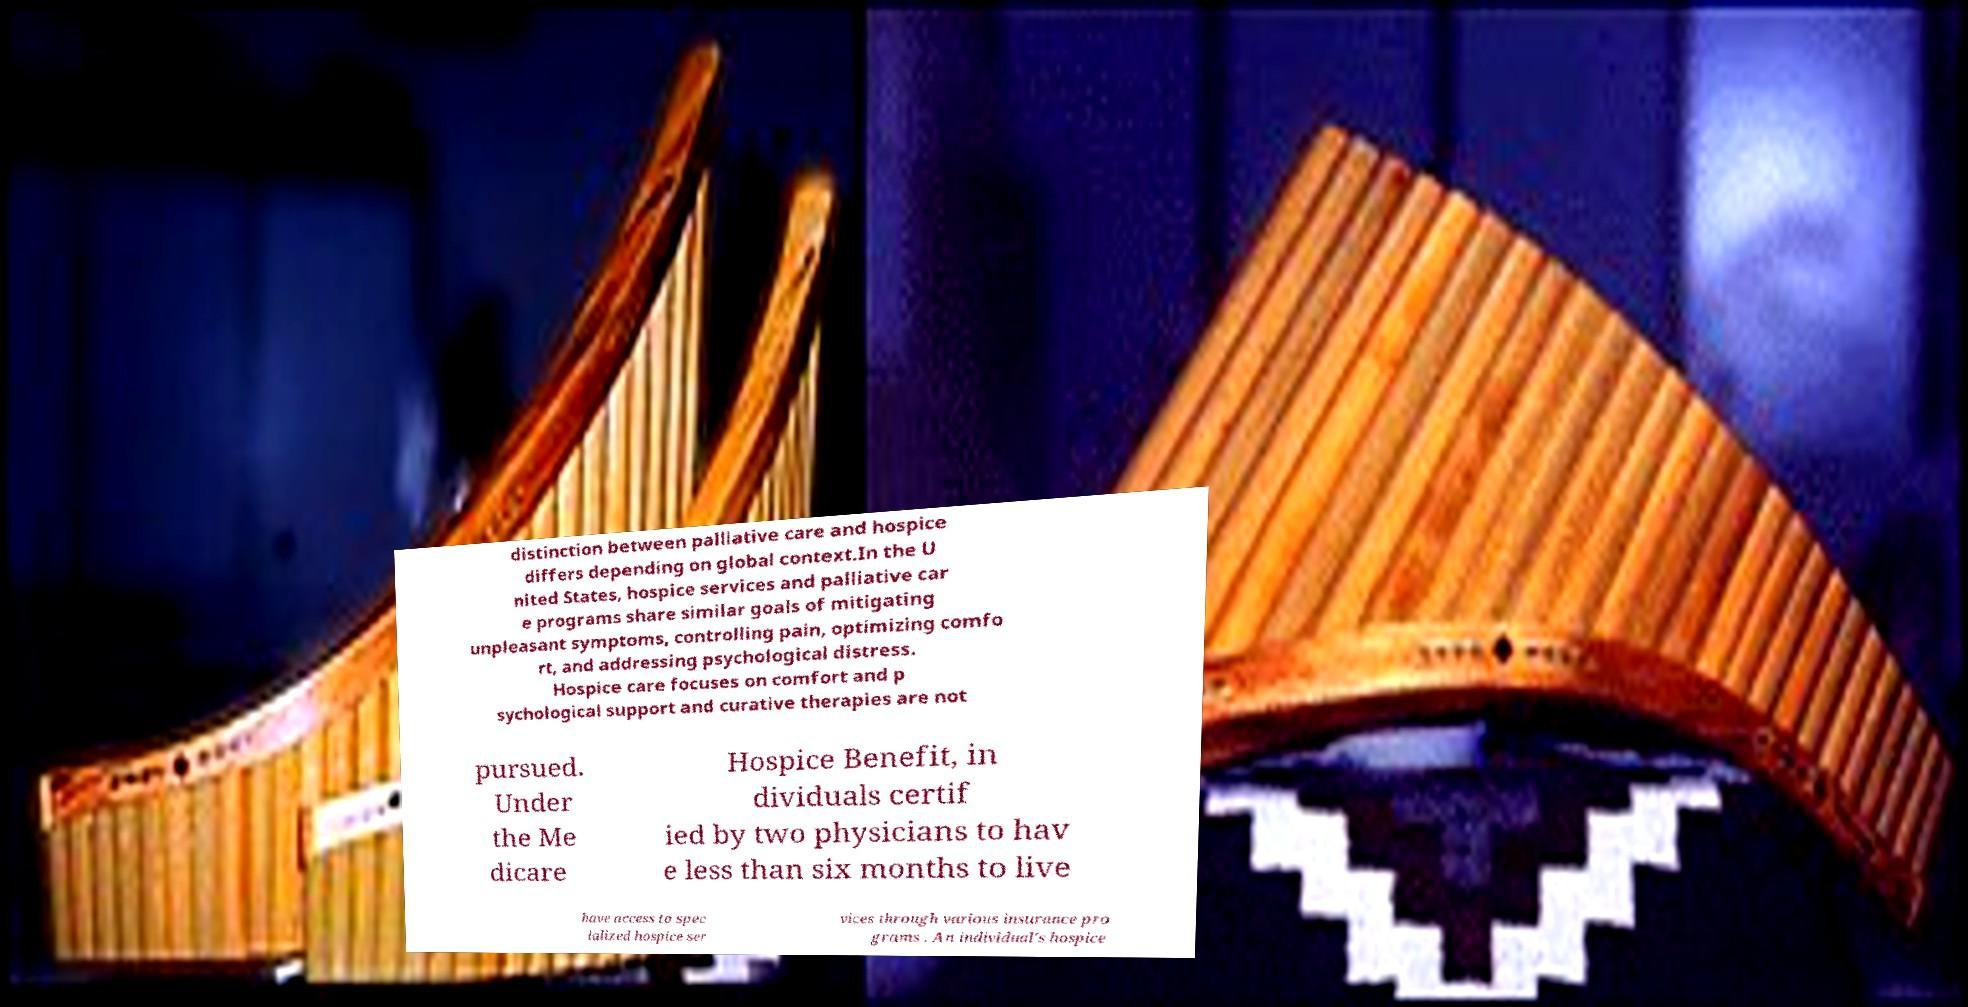Please read and relay the text visible in this image. What does it say? distinction between palliative care and hospice differs depending on global context.In the U nited States, hospice services and palliative car e programs share similar goals of mitigating unpleasant symptoms, controlling pain, optimizing comfo rt, and addressing psychological distress. Hospice care focuses on comfort and p sychological support and curative therapies are not pursued. Under the Me dicare Hospice Benefit, in dividuals certif ied by two physicians to hav e less than six months to live have access to spec ialized hospice ser vices through various insurance pro grams . An individual's hospice 